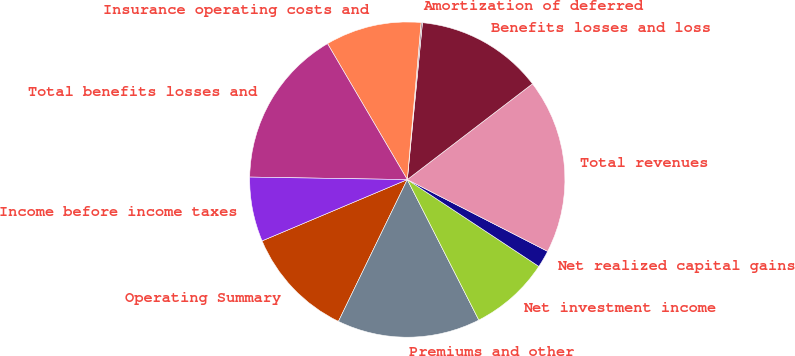<chart> <loc_0><loc_0><loc_500><loc_500><pie_chart><fcel>Operating Summary<fcel>Premiums and other<fcel>Net investment income<fcel>Net realized capital gains<fcel>Total revenues<fcel>Benefits losses and loss<fcel>Amortization of deferred<fcel>Insurance operating costs and<fcel>Total benefits losses and<fcel>Income before income taxes<nl><fcel>11.45%<fcel>14.69%<fcel>8.22%<fcel>1.76%<fcel>17.92%<fcel>13.07%<fcel>0.14%<fcel>9.84%<fcel>16.3%<fcel>6.61%<nl></chart> 